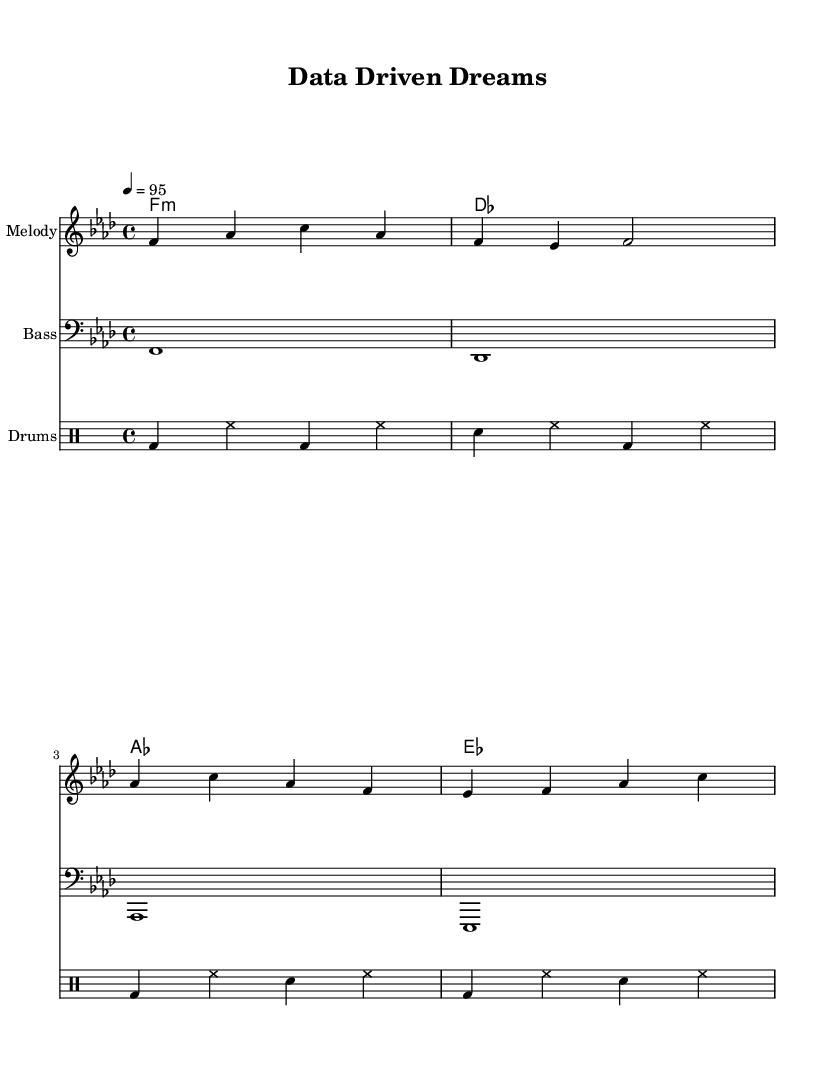What is the key signature of this music? The key signature is indicated at the beginning of the music. In this sheet music, it shows one flat, which corresponds to F minor.
Answer: F minor What is the time signature of the piece? The time signature is located just after the key signature at the beginning of the music. Here, it shows 4 over 4, which is a common time signature.
Answer: 4/4 What is the tempo marking for this piece? The tempo marking is located above the staff and indicates the speed of the music. It states "4 = 95," which means there are 95 beats per minute.
Answer: 95 How many measures are present in the melody section? The melody section consists of four groups of notes separated by vertical lines, known as bar lines. Counting these gives a total of four measures.
Answer: 4 What is the style of the song based on its lyrics? The lyrics mention "climbing higher" and "data-driven," which indicates a theme of motivation and determination, typical of motivational hip-hop songs.
Answer: Motivational hip-hop Which chord is played for the first measure? Looking at the chord names listed, the first chord in the first measure is labeled as "f1:m," indicating it is an F minor chord.
Answer: F minor 